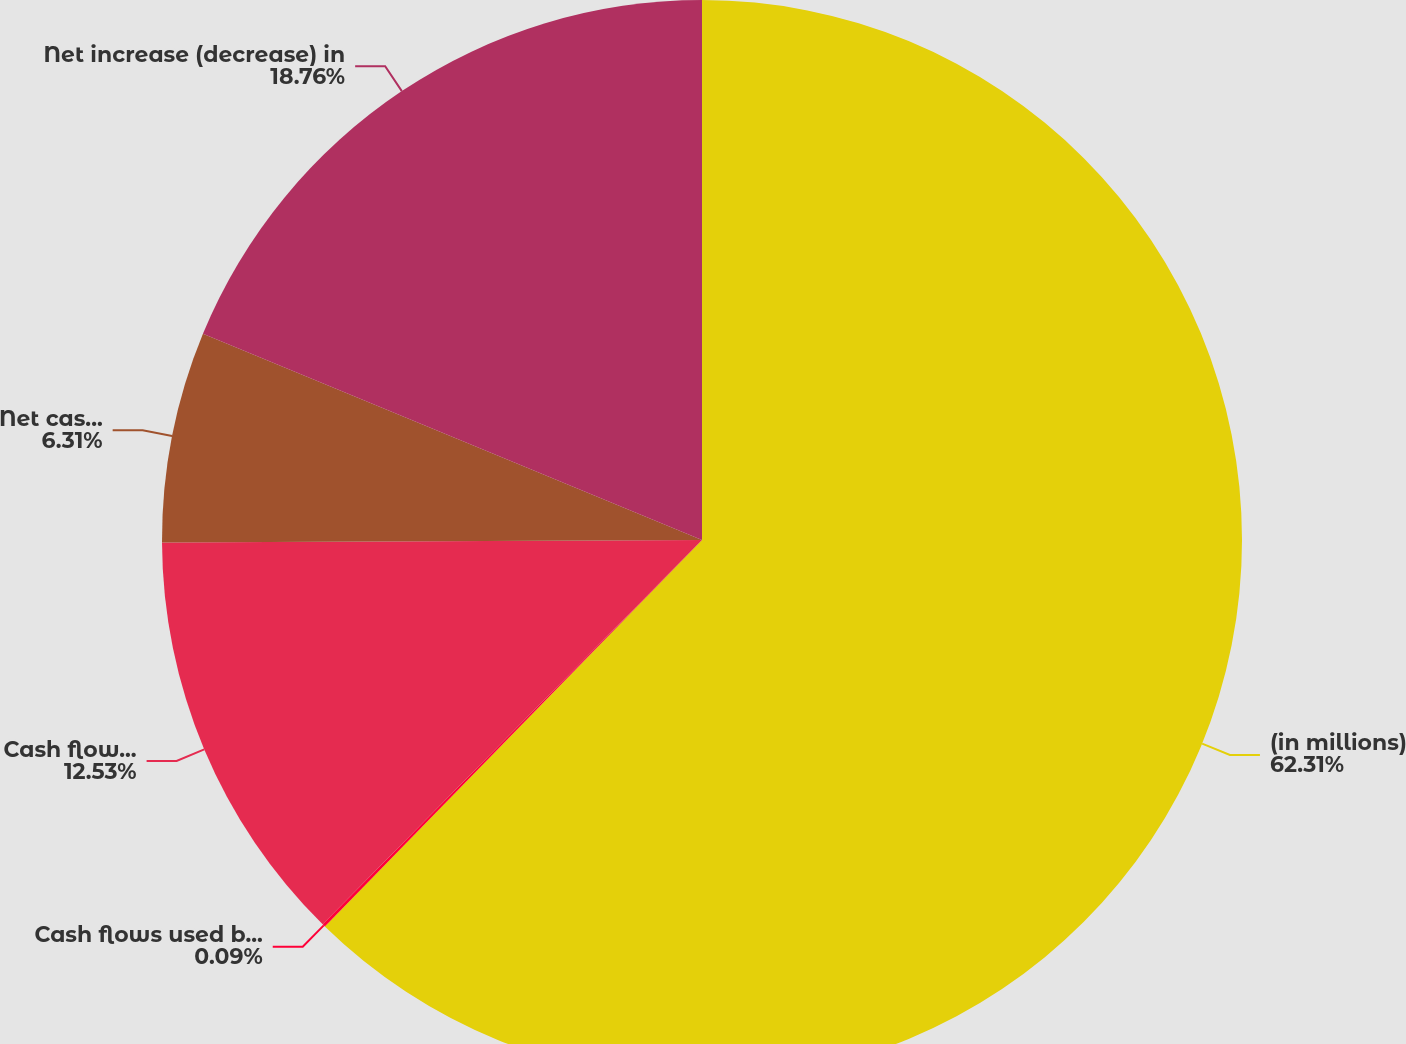Convert chart to OTSL. <chart><loc_0><loc_0><loc_500><loc_500><pie_chart><fcel>(in millions)<fcel>Cash flows used by operating<fcel>Cash flows provided (used) by<fcel>Net cash provided (used) by<fcel>Net increase (decrease) in<nl><fcel>62.3%<fcel>0.09%<fcel>12.53%<fcel>6.31%<fcel>18.76%<nl></chart> 